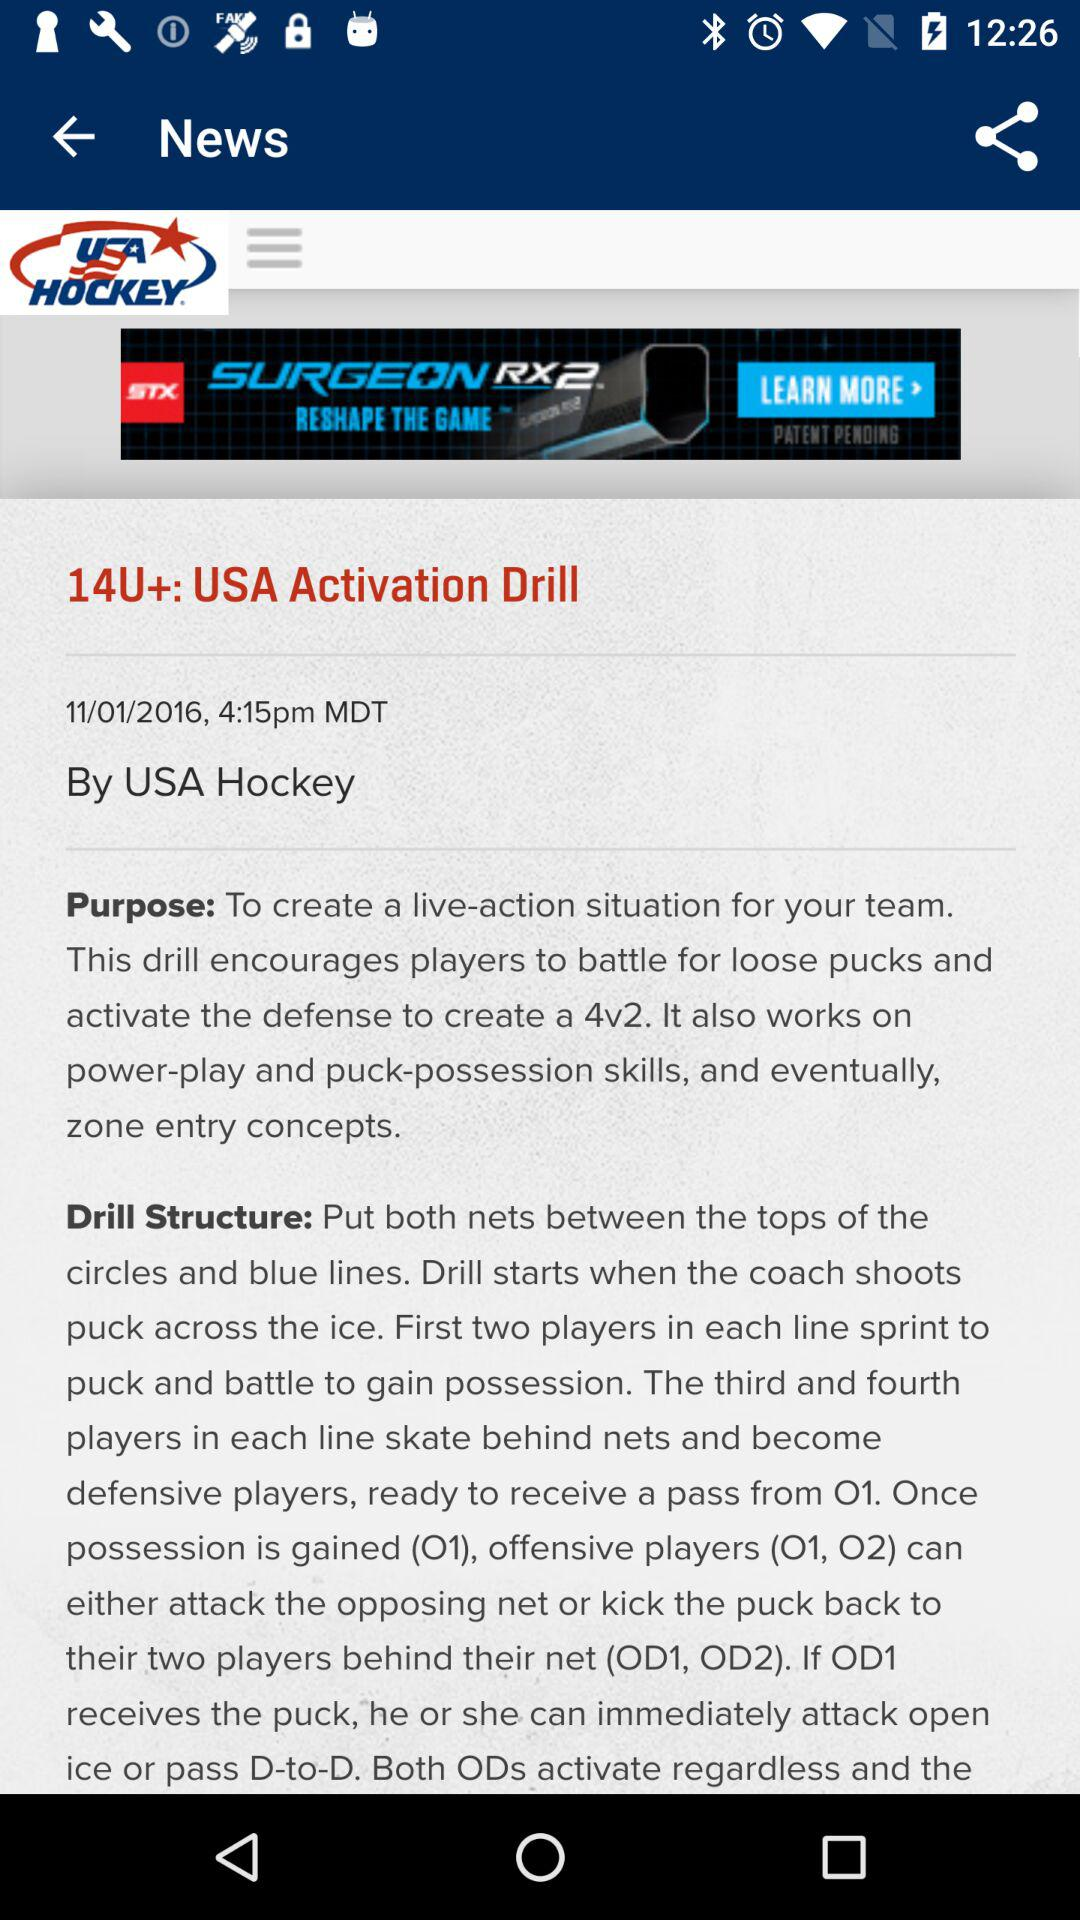How many players are in each line?
Answer the question using a single word or phrase. 4 